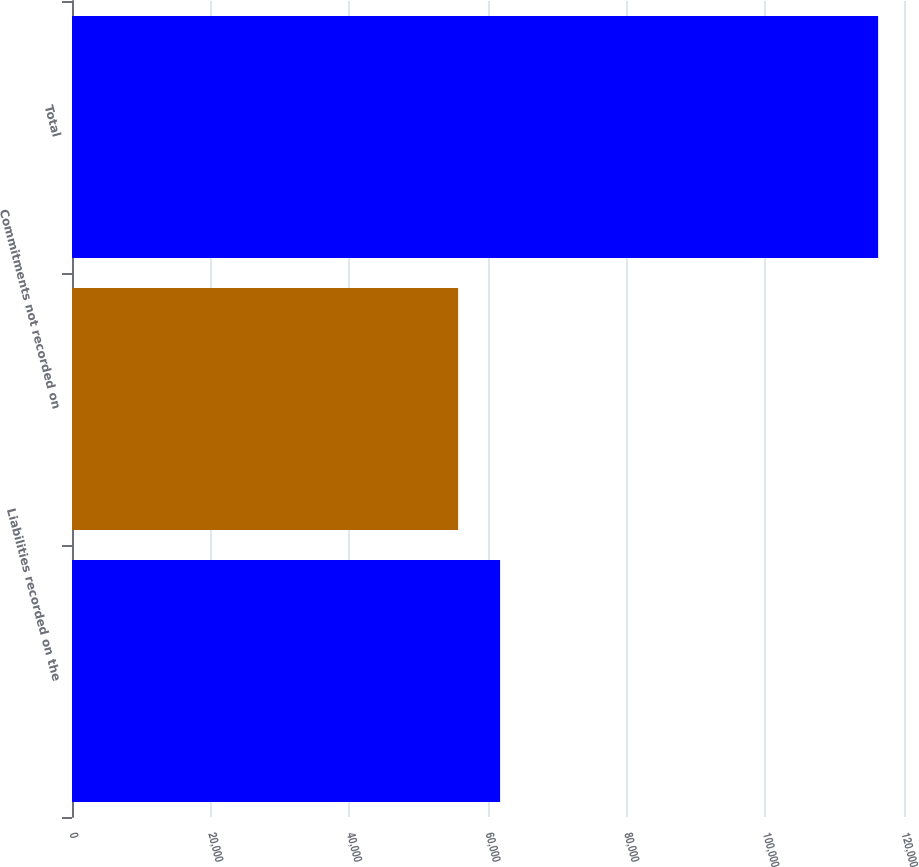Convert chart to OTSL. <chart><loc_0><loc_0><loc_500><loc_500><bar_chart><fcel>Liabilities recorded on the<fcel>Commitments not recorded on<fcel>Total<nl><fcel>61745.8<fcel>55688<fcel>116266<nl></chart> 